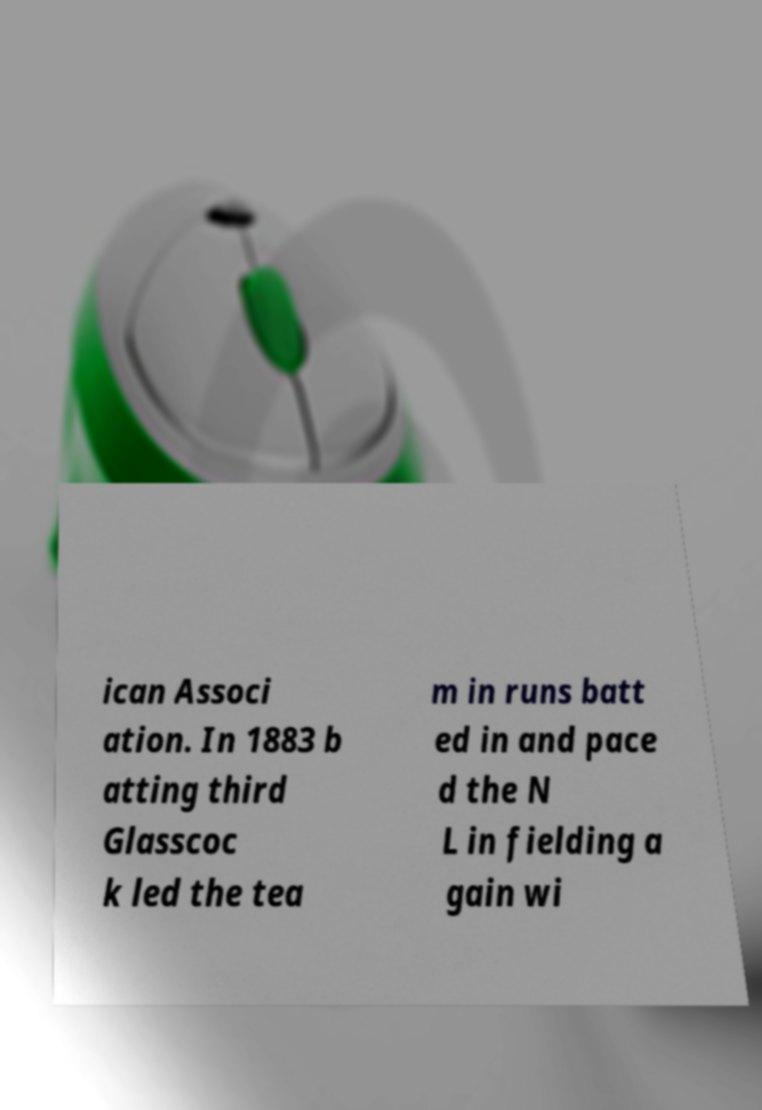Please identify and transcribe the text found in this image. ican Associ ation. In 1883 b atting third Glasscoc k led the tea m in runs batt ed in and pace d the N L in fielding a gain wi 